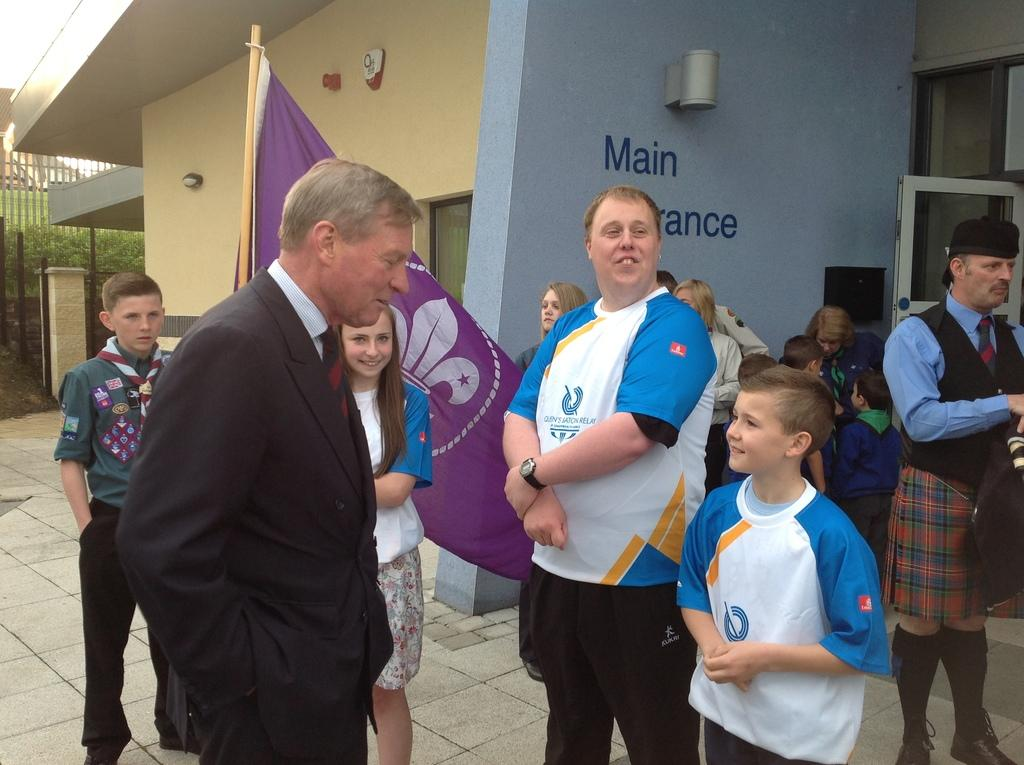What can be seen in the foreground of the image? There are people in the foreground of the image. What is the flag associated with in the image? The flag is visible in the image. What is located in the background of the image? There is a building in the background of the image. What architectural feature can be seen on the right side of the image? There is a window on the right side of the image. What is written or displayed on the wall of the building? There is text visible on the wall of the building. What type of cream is being traded in the image? There is no mention of cream or trading in the image. How many people have died in the image? There is no indication of death or any loss of life in the image. 